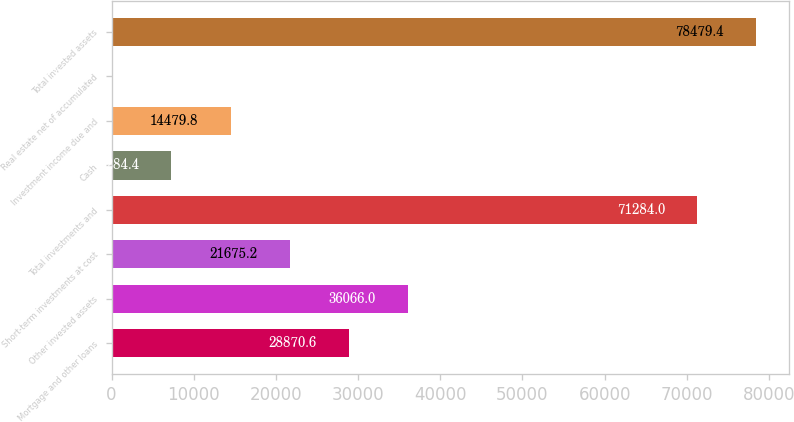Convert chart to OTSL. <chart><loc_0><loc_0><loc_500><loc_500><bar_chart><fcel>Mortgage and other loans<fcel>Other invested assets<fcel>Short-term investments at cost<fcel>Total investments and<fcel>Cash<fcel>Investment income due and<fcel>Real estate net of accumulated<fcel>Total invested assets<nl><fcel>28870.6<fcel>36066<fcel>21675.2<fcel>71284<fcel>7284.4<fcel>14479.8<fcel>89<fcel>78479.4<nl></chart> 